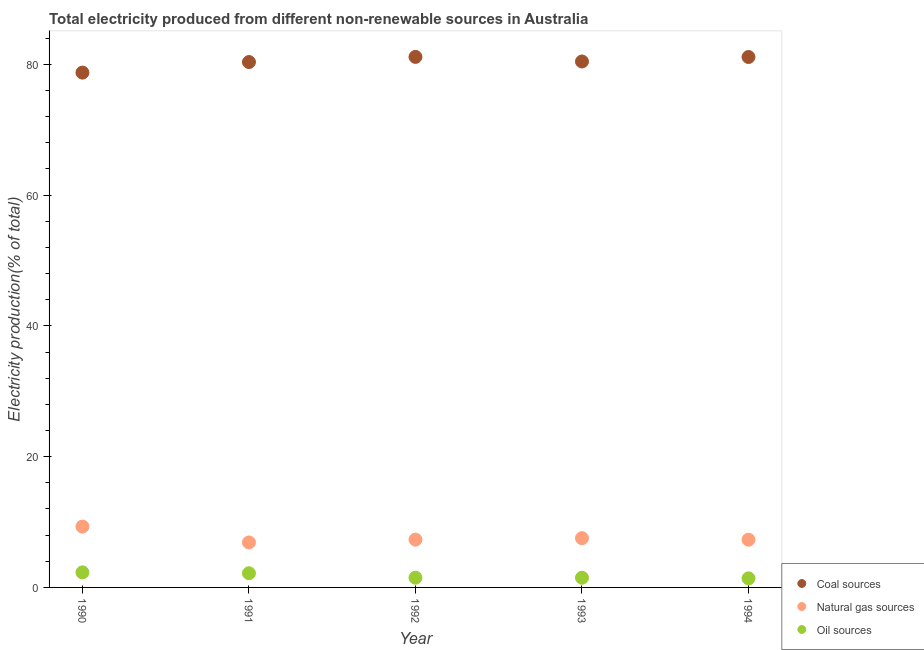How many different coloured dotlines are there?
Provide a short and direct response. 3. Is the number of dotlines equal to the number of legend labels?
Provide a succinct answer. Yes. What is the percentage of electricity produced by coal in 1990?
Offer a terse response. 78.74. Across all years, what is the maximum percentage of electricity produced by natural gas?
Give a very brief answer. 9.31. Across all years, what is the minimum percentage of electricity produced by coal?
Offer a very short reply. 78.74. What is the total percentage of electricity produced by coal in the graph?
Provide a short and direct response. 401.78. What is the difference between the percentage of electricity produced by coal in 1992 and that in 1993?
Offer a very short reply. 0.7. What is the difference between the percentage of electricity produced by coal in 1994 and the percentage of electricity produced by oil sources in 1990?
Your answer should be very brief. 78.82. What is the average percentage of electricity produced by oil sources per year?
Offer a very short reply. 1.77. In the year 1992, what is the difference between the percentage of electricity produced by oil sources and percentage of electricity produced by coal?
Provide a succinct answer. -79.65. In how many years, is the percentage of electricity produced by oil sources greater than 16 %?
Your response must be concise. 0. What is the ratio of the percentage of electricity produced by coal in 1992 to that in 1993?
Offer a terse response. 1.01. What is the difference between the highest and the second highest percentage of electricity produced by coal?
Keep it short and to the point. 0.02. What is the difference between the highest and the lowest percentage of electricity produced by oil sources?
Your answer should be very brief. 0.91. In how many years, is the percentage of electricity produced by coal greater than the average percentage of electricity produced by coal taken over all years?
Provide a succinct answer. 3. Is the percentage of electricity produced by natural gas strictly greater than the percentage of electricity produced by oil sources over the years?
Offer a very short reply. Yes. Is the percentage of electricity produced by natural gas strictly less than the percentage of electricity produced by coal over the years?
Provide a succinct answer. Yes. Does the graph contain any zero values?
Ensure brevity in your answer.  No. Where does the legend appear in the graph?
Your response must be concise. Bottom right. How many legend labels are there?
Provide a succinct answer. 3. How are the legend labels stacked?
Offer a very short reply. Vertical. What is the title of the graph?
Provide a succinct answer. Total electricity produced from different non-renewable sources in Australia. What is the label or title of the X-axis?
Keep it short and to the point. Year. What is the Electricity production(% of total) in Coal sources in 1990?
Provide a short and direct response. 78.74. What is the Electricity production(% of total) in Natural gas sources in 1990?
Provide a short and direct response. 9.31. What is the Electricity production(% of total) of Oil sources in 1990?
Your answer should be compact. 2.3. What is the Electricity production(% of total) in Coal sources in 1991?
Your response must be concise. 80.35. What is the Electricity production(% of total) in Natural gas sources in 1991?
Offer a terse response. 6.88. What is the Electricity production(% of total) of Oil sources in 1991?
Your answer should be very brief. 2.17. What is the Electricity production(% of total) in Coal sources in 1992?
Offer a very short reply. 81.14. What is the Electricity production(% of total) in Natural gas sources in 1992?
Provide a short and direct response. 7.31. What is the Electricity production(% of total) in Oil sources in 1992?
Your answer should be very brief. 1.48. What is the Electricity production(% of total) in Coal sources in 1993?
Ensure brevity in your answer.  80.44. What is the Electricity production(% of total) of Natural gas sources in 1993?
Give a very brief answer. 7.53. What is the Electricity production(% of total) in Oil sources in 1993?
Offer a terse response. 1.48. What is the Electricity production(% of total) of Coal sources in 1994?
Make the answer very short. 81.12. What is the Electricity production(% of total) in Natural gas sources in 1994?
Provide a succinct answer. 7.3. What is the Electricity production(% of total) of Oil sources in 1994?
Offer a terse response. 1.39. Across all years, what is the maximum Electricity production(% of total) of Coal sources?
Ensure brevity in your answer.  81.14. Across all years, what is the maximum Electricity production(% of total) in Natural gas sources?
Your answer should be compact. 9.31. Across all years, what is the maximum Electricity production(% of total) in Oil sources?
Provide a short and direct response. 2.3. Across all years, what is the minimum Electricity production(% of total) of Coal sources?
Ensure brevity in your answer.  78.74. Across all years, what is the minimum Electricity production(% of total) of Natural gas sources?
Your answer should be compact. 6.88. Across all years, what is the minimum Electricity production(% of total) in Oil sources?
Keep it short and to the point. 1.39. What is the total Electricity production(% of total) of Coal sources in the graph?
Your answer should be compact. 401.78. What is the total Electricity production(% of total) of Natural gas sources in the graph?
Make the answer very short. 38.33. What is the total Electricity production(% of total) in Oil sources in the graph?
Your answer should be compact. 8.83. What is the difference between the Electricity production(% of total) of Coal sources in 1990 and that in 1991?
Provide a succinct answer. -1.62. What is the difference between the Electricity production(% of total) in Natural gas sources in 1990 and that in 1991?
Make the answer very short. 2.43. What is the difference between the Electricity production(% of total) of Oil sources in 1990 and that in 1991?
Offer a terse response. 0.13. What is the difference between the Electricity production(% of total) in Coal sources in 1990 and that in 1992?
Your answer should be very brief. -2.4. What is the difference between the Electricity production(% of total) of Natural gas sources in 1990 and that in 1992?
Give a very brief answer. 2. What is the difference between the Electricity production(% of total) of Oil sources in 1990 and that in 1992?
Your answer should be very brief. 0.82. What is the difference between the Electricity production(% of total) of Coal sources in 1990 and that in 1993?
Give a very brief answer. -1.7. What is the difference between the Electricity production(% of total) of Natural gas sources in 1990 and that in 1993?
Give a very brief answer. 1.77. What is the difference between the Electricity production(% of total) in Oil sources in 1990 and that in 1993?
Keep it short and to the point. 0.82. What is the difference between the Electricity production(% of total) in Coal sources in 1990 and that in 1994?
Give a very brief answer. -2.39. What is the difference between the Electricity production(% of total) of Natural gas sources in 1990 and that in 1994?
Your response must be concise. 2.01. What is the difference between the Electricity production(% of total) in Oil sources in 1990 and that in 1994?
Provide a short and direct response. 0.91. What is the difference between the Electricity production(% of total) in Coal sources in 1991 and that in 1992?
Offer a terse response. -0.79. What is the difference between the Electricity production(% of total) in Natural gas sources in 1991 and that in 1992?
Make the answer very short. -0.43. What is the difference between the Electricity production(% of total) of Oil sources in 1991 and that in 1992?
Give a very brief answer. 0.69. What is the difference between the Electricity production(% of total) of Coal sources in 1991 and that in 1993?
Your answer should be very brief. -0.08. What is the difference between the Electricity production(% of total) in Natural gas sources in 1991 and that in 1993?
Make the answer very short. -0.65. What is the difference between the Electricity production(% of total) of Oil sources in 1991 and that in 1993?
Keep it short and to the point. 0.69. What is the difference between the Electricity production(% of total) in Coal sources in 1991 and that in 1994?
Offer a terse response. -0.77. What is the difference between the Electricity production(% of total) in Natural gas sources in 1991 and that in 1994?
Your answer should be compact. -0.42. What is the difference between the Electricity production(% of total) in Oil sources in 1991 and that in 1994?
Provide a succinct answer. 0.78. What is the difference between the Electricity production(% of total) of Coal sources in 1992 and that in 1993?
Give a very brief answer. 0.7. What is the difference between the Electricity production(% of total) of Natural gas sources in 1992 and that in 1993?
Your answer should be compact. -0.22. What is the difference between the Electricity production(% of total) in Oil sources in 1992 and that in 1993?
Offer a terse response. 0. What is the difference between the Electricity production(% of total) in Coal sources in 1992 and that in 1994?
Make the answer very short. 0.02. What is the difference between the Electricity production(% of total) in Natural gas sources in 1992 and that in 1994?
Provide a succinct answer. 0.01. What is the difference between the Electricity production(% of total) of Oil sources in 1992 and that in 1994?
Your response must be concise. 0.1. What is the difference between the Electricity production(% of total) in Coal sources in 1993 and that in 1994?
Ensure brevity in your answer.  -0.68. What is the difference between the Electricity production(% of total) of Natural gas sources in 1993 and that in 1994?
Provide a short and direct response. 0.23. What is the difference between the Electricity production(% of total) of Oil sources in 1993 and that in 1994?
Provide a short and direct response. 0.1. What is the difference between the Electricity production(% of total) in Coal sources in 1990 and the Electricity production(% of total) in Natural gas sources in 1991?
Your answer should be compact. 71.85. What is the difference between the Electricity production(% of total) of Coal sources in 1990 and the Electricity production(% of total) of Oil sources in 1991?
Provide a short and direct response. 76.57. What is the difference between the Electricity production(% of total) in Natural gas sources in 1990 and the Electricity production(% of total) in Oil sources in 1991?
Your answer should be compact. 7.14. What is the difference between the Electricity production(% of total) of Coal sources in 1990 and the Electricity production(% of total) of Natural gas sources in 1992?
Provide a short and direct response. 71.42. What is the difference between the Electricity production(% of total) of Coal sources in 1990 and the Electricity production(% of total) of Oil sources in 1992?
Your answer should be compact. 77.25. What is the difference between the Electricity production(% of total) of Natural gas sources in 1990 and the Electricity production(% of total) of Oil sources in 1992?
Your response must be concise. 7.82. What is the difference between the Electricity production(% of total) in Coal sources in 1990 and the Electricity production(% of total) in Natural gas sources in 1993?
Make the answer very short. 71.2. What is the difference between the Electricity production(% of total) in Coal sources in 1990 and the Electricity production(% of total) in Oil sources in 1993?
Offer a terse response. 77.25. What is the difference between the Electricity production(% of total) in Natural gas sources in 1990 and the Electricity production(% of total) in Oil sources in 1993?
Offer a terse response. 7.82. What is the difference between the Electricity production(% of total) in Coal sources in 1990 and the Electricity production(% of total) in Natural gas sources in 1994?
Make the answer very short. 71.44. What is the difference between the Electricity production(% of total) of Coal sources in 1990 and the Electricity production(% of total) of Oil sources in 1994?
Offer a terse response. 77.35. What is the difference between the Electricity production(% of total) in Natural gas sources in 1990 and the Electricity production(% of total) in Oil sources in 1994?
Give a very brief answer. 7.92. What is the difference between the Electricity production(% of total) of Coal sources in 1991 and the Electricity production(% of total) of Natural gas sources in 1992?
Provide a succinct answer. 73.04. What is the difference between the Electricity production(% of total) of Coal sources in 1991 and the Electricity production(% of total) of Oil sources in 1992?
Your answer should be very brief. 78.87. What is the difference between the Electricity production(% of total) of Natural gas sources in 1991 and the Electricity production(% of total) of Oil sources in 1992?
Your answer should be compact. 5.4. What is the difference between the Electricity production(% of total) in Coal sources in 1991 and the Electricity production(% of total) in Natural gas sources in 1993?
Offer a terse response. 72.82. What is the difference between the Electricity production(% of total) in Coal sources in 1991 and the Electricity production(% of total) in Oil sources in 1993?
Provide a short and direct response. 78.87. What is the difference between the Electricity production(% of total) of Natural gas sources in 1991 and the Electricity production(% of total) of Oil sources in 1993?
Give a very brief answer. 5.4. What is the difference between the Electricity production(% of total) in Coal sources in 1991 and the Electricity production(% of total) in Natural gas sources in 1994?
Provide a succinct answer. 73.05. What is the difference between the Electricity production(% of total) of Coal sources in 1991 and the Electricity production(% of total) of Oil sources in 1994?
Your response must be concise. 78.96. What is the difference between the Electricity production(% of total) in Natural gas sources in 1991 and the Electricity production(% of total) in Oil sources in 1994?
Ensure brevity in your answer.  5.49. What is the difference between the Electricity production(% of total) of Coal sources in 1992 and the Electricity production(% of total) of Natural gas sources in 1993?
Provide a short and direct response. 73.61. What is the difference between the Electricity production(% of total) of Coal sources in 1992 and the Electricity production(% of total) of Oil sources in 1993?
Provide a succinct answer. 79.66. What is the difference between the Electricity production(% of total) in Natural gas sources in 1992 and the Electricity production(% of total) in Oil sources in 1993?
Provide a short and direct response. 5.83. What is the difference between the Electricity production(% of total) of Coal sources in 1992 and the Electricity production(% of total) of Natural gas sources in 1994?
Give a very brief answer. 73.84. What is the difference between the Electricity production(% of total) of Coal sources in 1992 and the Electricity production(% of total) of Oil sources in 1994?
Your answer should be compact. 79.75. What is the difference between the Electricity production(% of total) in Natural gas sources in 1992 and the Electricity production(% of total) in Oil sources in 1994?
Your response must be concise. 5.92. What is the difference between the Electricity production(% of total) of Coal sources in 1993 and the Electricity production(% of total) of Natural gas sources in 1994?
Give a very brief answer. 73.14. What is the difference between the Electricity production(% of total) in Coal sources in 1993 and the Electricity production(% of total) in Oil sources in 1994?
Provide a succinct answer. 79.05. What is the difference between the Electricity production(% of total) in Natural gas sources in 1993 and the Electricity production(% of total) in Oil sources in 1994?
Your response must be concise. 6.14. What is the average Electricity production(% of total) in Coal sources per year?
Offer a very short reply. 80.36. What is the average Electricity production(% of total) in Natural gas sources per year?
Provide a short and direct response. 7.67. What is the average Electricity production(% of total) of Oil sources per year?
Provide a short and direct response. 1.77. In the year 1990, what is the difference between the Electricity production(% of total) in Coal sources and Electricity production(% of total) in Natural gas sources?
Offer a very short reply. 69.43. In the year 1990, what is the difference between the Electricity production(% of total) in Coal sources and Electricity production(% of total) in Oil sources?
Your answer should be very brief. 76.43. In the year 1990, what is the difference between the Electricity production(% of total) in Natural gas sources and Electricity production(% of total) in Oil sources?
Ensure brevity in your answer.  7. In the year 1991, what is the difference between the Electricity production(% of total) in Coal sources and Electricity production(% of total) in Natural gas sources?
Offer a very short reply. 73.47. In the year 1991, what is the difference between the Electricity production(% of total) in Coal sources and Electricity production(% of total) in Oil sources?
Ensure brevity in your answer.  78.18. In the year 1991, what is the difference between the Electricity production(% of total) of Natural gas sources and Electricity production(% of total) of Oil sources?
Keep it short and to the point. 4.71. In the year 1992, what is the difference between the Electricity production(% of total) in Coal sources and Electricity production(% of total) in Natural gas sources?
Your response must be concise. 73.83. In the year 1992, what is the difference between the Electricity production(% of total) in Coal sources and Electricity production(% of total) in Oil sources?
Give a very brief answer. 79.65. In the year 1992, what is the difference between the Electricity production(% of total) of Natural gas sources and Electricity production(% of total) of Oil sources?
Your answer should be compact. 5.83. In the year 1993, what is the difference between the Electricity production(% of total) of Coal sources and Electricity production(% of total) of Natural gas sources?
Make the answer very short. 72.9. In the year 1993, what is the difference between the Electricity production(% of total) in Coal sources and Electricity production(% of total) in Oil sources?
Your answer should be very brief. 78.95. In the year 1993, what is the difference between the Electricity production(% of total) of Natural gas sources and Electricity production(% of total) of Oil sources?
Offer a very short reply. 6.05. In the year 1994, what is the difference between the Electricity production(% of total) of Coal sources and Electricity production(% of total) of Natural gas sources?
Make the answer very short. 73.82. In the year 1994, what is the difference between the Electricity production(% of total) in Coal sources and Electricity production(% of total) in Oil sources?
Ensure brevity in your answer.  79.73. In the year 1994, what is the difference between the Electricity production(% of total) in Natural gas sources and Electricity production(% of total) in Oil sources?
Ensure brevity in your answer.  5.91. What is the ratio of the Electricity production(% of total) of Coal sources in 1990 to that in 1991?
Provide a short and direct response. 0.98. What is the ratio of the Electricity production(% of total) of Natural gas sources in 1990 to that in 1991?
Offer a terse response. 1.35. What is the ratio of the Electricity production(% of total) of Oil sources in 1990 to that in 1991?
Ensure brevity in your answer.  1.06. What is the ratio of the Electricity production(% of total) of Coal sources in 1990 to that in 1992?
Offer a very short reply. 0.97. What is the ratio of the Electricity production(% of total) in Natural gas sources in 1990 to that in 1992?
Your response must be concise. 1.27. What is the ratio of the Electricity production(% of total) of Oil sources in 1990 to that in 1992?
Provide a short and direct response. 1.55. What is the ratio of the Electricity production(% of total) in Coal sources in 1990 to that in 1993?
Provide a succinct answer. 0.98. What is the ratio of the Electricity production(% of total) of Natural gas sources in 1990 to that in 1993?
Give a very brief answer. 1.24. What is the ratio of the Electricity production(% of total) in Oil sources in 1990 to that in 1993?
Your answer should be compact. 1.55. What is the ratio of the Electricity production(% of total) of Coal sources in 1990 to that in 1994?
Make the answer very short. 0.97. What is the ratio of the Electricity production(% of total) of Natural gas sources in 1990 to that in 1994?
Keep it short and to the point. 1.28. What is the ratio of the Electricity production(% of total) of Oil sources in 1990 to that in 1994?
Make the answer very short. 1.66. What is the ratio of the Electricity production(% of total) of Coal sources in 1991 to that in 1992?
Provide a succinct answer. 0.99. What is the ratio of the Electricity production(% of total) in Natural gas sources in 1991 to that in 1992?
Offer a very short reply. 0.94. What is the ratio of the Electricity production(% of total) in Oil sources in 1991 to that in 1992?
Offer a very short reply. 1.46. What is the ratio of the Electricity production(% of total) in Natural gas sources in 1991 to that in 1993?
Keep it short and to the point. 0.91. What is the ratio of the Electricity production(% of total) in Oil sources in 1991 to that in 1993?
Your response must be concise. 1.46. What is the ratio of the Electricity production(% of total) of Coal sources in 1991 to that in 1994?
Your answer should be compact. 0.99. What is the ratio of the Electricity production(% of total) in Natural gas sources in 1991 to that in 1994?
Ensure brevity in your answer.  0.94. What is the ratio of the Electricity production(% of total) of Oil sources in 1991 to that in 1994?
Your answer should be very brief. 1.56. What is the ratio of the Electricity production(% of total) of Coal sources in 1992 to that in 1993?
Your answer should be very brief. 1.01. What is the ratio of the Electricity production(% of total) of Natural gas sources in 1992 to that in 1993?
Ensure brevity in your answer.  0.97. What is the ratio of the Electricity production(% of total) in Natural gas sources in 1992 to that in 1994?
Provide a short and direct response. 1. What is the ratio of the Electricity production(% of total) in Oil sources in 1992 to that in 1994?
Keep it short and to the point. 1.07. What is the ratio of the Electricity production(% of total) in Natural gas sources in 1993 to that in 1994?
Make the answer very short. 1.03. What is the ratio of the Electricity production(% of total) of Oil sources in 1993 to that in 1994?
Your answer should be compact. 1.07. What is the difference between the highest and the second highest Electricity production(% of total) in Coal sources?
Your response must be concise. 0.02. What is the difference between the highest and the second highest Electricity production(% of total) in Natural gas sources?
Make the answer very short. 1.77. What is the difference between the highest and the second highest Electricity production(% of total) in Oil sources?
Offer a terse response. 0.13. What is the difference between the highest and the lowest Electricity production(% of total) of Coal sources?
Offer a terse response. 2.4. What is the difference between the highest and the lowest Electricity production(% of total) in Natural gas sources?
Your response must be concise. 2.43. What is the difference between the highest and the lowest Electricity production(% of total) of Oil sources?
Ensure brevity in your answer.  0.91. 